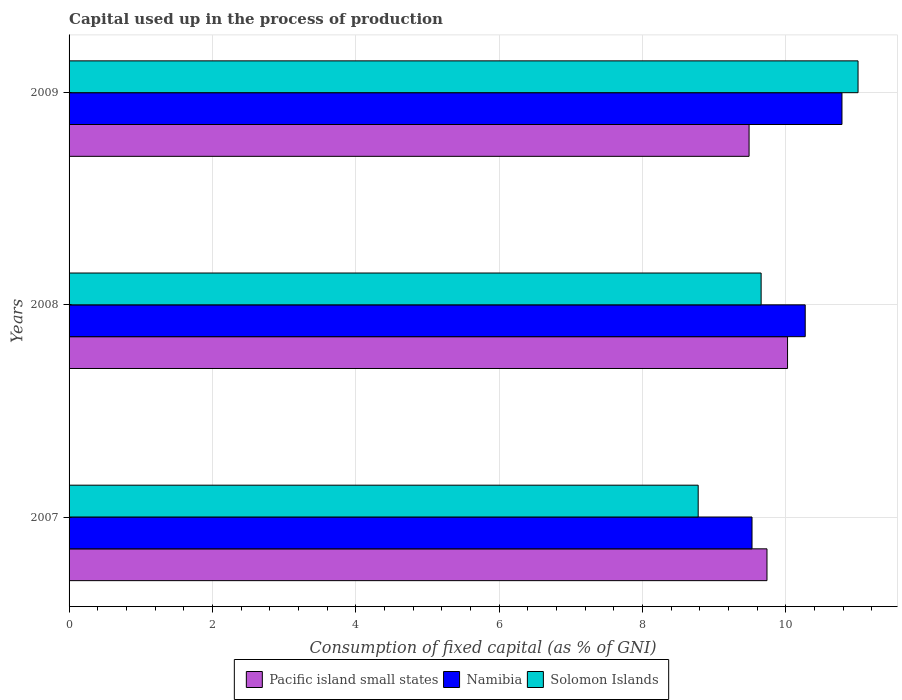How many different coloured bars are there?
Offer a terse response. 3. Are the number of bars per tick equal to the number of legend labels?
Your response must be concise. Yes. How many bars are there on the 3rd tick from the top?
Provide a succinct answer. 3. How many bars are there on the 3rd tick from the bottom?
Provide a short and direct response. 3. What is the label of the 1st group of bars from the top?
Ensure brevity in your answer.  2009. What is the capital used up in the process of production in Namibia in 2008?
Your answer should be compact. 10.27. Across all years, what is the maximum capital used up in the process of production in Solomon Islands?
Keep it short and to the point. 11.01. Across all years, what is the minimum capital used up in the process of production in Pacific island small states?
Your answer should be compact. 9.49. In which year was the capital used up in the process of production in Namibia minimum?
Ensure brevity in your answer.  2007. What is the total capital used up in the process of production in Solomon Islands in the graph?
Offer a very short reply. 29.44. What is the difference between the capital used up in the process of production in Solomon Islands in 2008 and that in 2009?
Keep it short and to the point. -1.35. What is the difference between the capital used up in the process of production in Namibia in 2008 and the capital used up in the process of production in Pacific island small states in 2007?
Ensure brevity in your answer.  0.53. What is the average capital used up in the process of production in Solomon Islands per year?
Your answer should be very brief. 9.81. In the year 2009, what is the difference between the capital used up in the process of production in Solomon Islands and capital used up in the process of production in Namibia?
Provide a short and direct response. 0.22. What is the ratio of the capital used up in the process of production in Pacific island small states in 2007 to that in 2008?
Ensure brevity in your answer.  0.97. Is the difference between the capital used up in the process of production in Solomon Islands in 2007 and 2009 greater than the difference between the capital used up in the process of production in Namibia in 2007 and 2009?
Give a very brief answer. No. What is the difference between the highest and the second highest capital used up in the process of production in Pacific island small states?
Your response must be concise. 0.29. What is the difference between the highest and the lowest capital used up in the process of production in Solomon Islands?
Offer a terse response. 2.23. In how many years, is the capital used up in the process of production in Solomon Islands greater than the average capital used up in the process of production in Solomon Islands taken over all years?
Provide a short and direct response. 1. Is the sum of the capital used up in the process of production in Namibia in 2007 and 2009 greater than the maximum capital used up in the process of production in Solomon Islands across all years?
Make the answer very short. Yes. What does the 1st bar from the top in 2007 represents?
Your answer should be very brief. Solomon Islands. What does the 2nd bar from the bottom in 2007 represents?
Offer a terse response. Namibia. Is it the case that in every year, the sum of the capital used up in the process of production in Solomon Islands and capital used up in the process of production in Pacific island small states is greater than the capital used up in the process of production in Namibia?
Provide a short and direct response. Yes. How many bars are there?
Make the answer very short. 9. Are all the bars in the graph horizontal?
Provide a short and direct response. Yes. How many years are there in the graph?
Make the answer very short. 3. Are the values on the major ticks of X-axis written in scientific E-notation?
Your answer should be compact. No. Does the graph contain any zero values?
Keep it short and to the point. No. Where does the legend appear in the graph?
Your response must be concise. Bottom center. How many legend labels are there?
Provide a short and direct response. 3. How are the legend labels stacked?
Make the answer very short. Horizontal. What is the title of the graph?
Offer a terse response. Capital used up in the process of production. What is the label or title of the X-axis?
Keep it short and to the point. Consumption of fixed capital (as % of GNI). What is the label or title of the Y-axis?
Offer a terse response. Years. What is the Consumption of fixed capital (as % of GNI) of Pacific island small states in 2007?
Make the answer very short. 9.74. What is the Consumption of fixed capital (as % of GNI) of Namibia in 2007?
Provide a short and direct response. 9.53. What is the Consumption of fixed capital (as % of GNI) in Solomon Islands in 2007?
Provide a succinct answer. 8.78. What is the Consumption of fixed capital (as % of GNI) in Pacific island small states in 2008?
Your answer should be compact. 10.03. What is the Consumption of fixed capital (as % of GNI) of Namibia in 2008?
Your answer should be compact. 10.27. What is the Consumption of fixed capital (as % of GNI) of Solomon Islands in 2008?
Ensure brevity in your answer.  9.66. What is the Consumption of fixed capital (as % of GNI) of Pacific island small states in 2009?
Provide a short and direct response. 9.49. What is the Consumption of fixed capital (as % of GNI) of Namibia in 2009?
Make the answer very short. 10.78. What is the Consumption of fixed capital (as % of GNI) in Solomon Islands in 2009?
Make the answer very short. 11.01. Across all years, what is the maximum Consumption of fixed capital (as % of GNI) of Pacific island small states?
Keep it short and to the point. 10.03. Across all years, what is the maximum Consumption of fixed capital (as % of GNI) in Namibia?
Your answer should be compact. 10.78. Across all years, what is the maximum Consumption of fixed capital (as % of GNI) of Solomon Islands?
Your response must be concise. 11.01. Across all years, what is the minimum Consumption of fixed capital (as % of GNI) in Pacific island small states?
Keep it short and to the point. 9.49. Across all years, what is the minimum Consumption of fixed capital (as % of GNI) of Namibia?
Offer a terse response. 9.53. Across all years, what is the minimum Consumption of fixed capital (as % of GNI) in Solomon Islands?
Offer a terse response. 8.78. What is the total Consumption of fixed capital (as % of GNI) of Pacific island small states in the graph?
Provide a short and direct response. 29.25. What is the total Consumption of fixed capital (as % of GNI) of Namibia in the graph?
Provide a succinct answer. 30.59. What is the total Consumption of fixed capital (as % of GNI) of Solomon Islands in the graph?
Your response must be concise. 29.44. What is the difference between the Consumption of fixed capital (as % of GNI) in Pacific island small states in 2007 and that in 2008?
Ensure brevity in your answer.  -0.29. What is the difference between the Consumption of fixed capital (as % of GNI) in Namibia in 2007 and that in 2008?
Provide a short and direct response. -0.74. What is the difference between the Consumption of fixed capital (as % of GNI) of Solomon Islands in 2007 and that in 2008?
Offer a terse response. -0.88. What is the difference between the Consumption of fixed capital (as % of GNI) of Pacific island small states in 2007 and that in 2009?
Keep it short and to the point. 0.25. What is the difference between the Consumption of fixed capital (as % of GNI) in Namibia in 2007 and that in 2009?
Keep it short and to the point. -1.26. What is the difference between the Consumption of fixed capital (as % of GNI) in Solomon Islands in 2007 and that in 2009?
Your answer should be very brief. -2.23. What is the difference between the Consumption of fixed capital (as % of GNI) in Pacific island small states in 2008 and that in 2009?
Provide a succinct answer. 0.54. What is the difference between the Consumption of fixed capital (as % of GNI) in Namibia in 2008 and that in 2009?
Offer a terse response. -0.51. What is the difference between the Consumption of fixed capital (as % of GNI) of Solomon Islands in 2008 and that in 2009?
Ensure brevity in your answer.  -1.35. What is the difference between the Consumption of fixed capital (as % of GNI) of Pacific island small states in 2007 and the Consumption of fixed capital (as % of GNI) of Namibia in 2008?
Ensure brevity in your answer.  -0.53. What is the difference between the Consumption of fixed capital (as % of GNI) in Pacific island small states in 2007 and the Consumption of fixed capital (as % of GNI) in Solomon Islands in 2008?
Provide a short and direct response. 0.08. What is the difference between the Consumption of fixed capital (as % of GNI) in Namibia in 2007 and the Consumption of fixed capital (as % of GNI) in Solomon Islands in 2008?
Ensure brevity in your answer.  -0.13. What is the difference between the Consumption of fixed capital (as % of GNI) of Pacific island small states in 2007 and the Consumption of fixed capital (as % of GNI) of Namibia in 2009?
Your answer should be very brief. -1.05. What is the difference between the Consumption of fixed capital (as % of GNI) of Pacific island small states in 2007 and the Consumption of fixed capital (as % of GNI) of Solomon Islands in 2009?
Your response must be concise. -1.27. What is the difference between the Consumption of fixed capital (as % of GNI) of Namibia in 2007 and the Consumption of fixed capital (as % of GNI) of Solomon Islands in 2009?
Your answer should be compact. -1.48. What is the difference between the Consumption of fixed capital (as % of GNI) in Pacific island small states in 2008 and the Consumption of fixed capital (as % of GNI) in Namibia in 2009?
Provide a succinct answer. -0.76. What is the difference between the Consumption of fixed capital (as % of GNI) in Pacific island small states in 2008 and the Consumption of fixed capital (as % of GNI) in Solomon Islands in 2009?
Offer a very short reply. -0.98. What is the difference between the Consumption of fixed capital (as % of GNI) in Namibia in 2008 and the Consumption of fixed capital (as % of GNI) in Solomon Islands in 2009?
Your answer should be compact. -0.74. What is the average Consumption of fixed capital (as % of GNI) of Pacific island small states per year?
Your answer should be very brief. 9.75. What is the average Consumption of fixed capital (as % of GNI) of Namibia per year?
Make the answer very short. 10.2. What is the average Consumption of fixed capital (as % of GNI) of Solomon Islands per year?
Make the answer very short. 9.81. In the year 2007, what is the difference between the Consumption of fixed capital (as % of GNI) of Pacific island small states and Consumption of fixed capital (as % of GNI) of Namibia?
Provide a succinct answer. 0.21. In the year 2007, what is the difference between the Consumption of fixed capital (as % of GNI) in Namibia and Consumption of fixed capital (as % of GNI) in Solomon Islands?
Make the answer very short. 0.75. In the year 2008, what is the difference between the Consumption of fixed capital (as % of GNI) of Pacific island small states and Consumption of fixed capital (as % of GNI) of Namibia?
Provide a succinct answer. -0.25. In the year 2008, what is the difference between the Consumption of fixed capital (as % of GNI) of Pacific island small states and Consumption of fixed capital (as % of GNI) of Solomon Islands?
Offer a terse response. 0.37. In the year 2008, what is the difference between the Consumption of fixed capital (as % of GNI) in Namibia and Consumption of fixed capital (as % of GNI) in Solomon Islands?
Make the answer very short. 0.62. In the year 2009, what is the difference between the Consumption of fixed capital (as % of GNI) in Pacific island small states and Consumption of fixed capital (as % of GNI) in Namibia?
Your answer should be very brief. -1.3. In the year 2009, what is the difference between the Consumption of fixed capital (as % of GNI) in Pacific island small states and Consumption of fixed capital (as % of GNI) in Solomon Islands?
Offer a very short reply. -1.52. In the year 2009, what is the difference between the Consumption of fixed capital (as % of GNI) of Namibia and Consumption of fixed capital (as % of GNI) of Solomon Islands?
Provide a succinct answer. -0.22. What is the ratio of the Consumption of fixed capital (as % of GNI) in Pacific island small states in 2007 to that in 2008?
Your answer should be very brief. 0.97. What is the ratio of the Consumption of fixed capital (as % of GNI) in Namibia in 2007 to that in 2008?
Provide a short and direct response. 0.93. What is the ratio of the Consumption of fixed capital (as % of GNI) of Solomon Islands in 2007 to that in 2008?
Give a very brief answer. 0.91. What is the ratio of the Consumption of fixed capital (as % of GNI) in Pacific island small states in 2007 to that in 2009?
Your response must be concise. 1.03. What is the ratio of the Consumption of fixed capital (as % of GNI) of Namibia in 2007 to that in 2009?
Give a very brief answer. 0.88. What is the ratio of the Consumption of fixed capital (as % of GNI) in Solomon Islands in 2007 to that in 2009?
Give a very brief answer. 0.8. What is the ratio of the Consumption of fixed capital (as % of GNI) in Pacific island small states in 2008 to that in 2009?
Ensure brevity in your answer.  1.06. What is the ratio of the Consumption of fixed capital (as % of GNI) in Namibia in 2008 to that in 2009?
Offer a very short reply. 0.95. What is the ratio of the Consumption of fixed capital (as % of GNI) in Solomon Islands in 2008 to that in 2009?
Give a very brief answer. 0.88. What is the difference between the highest and the second highest Consumption of fixed capital (as % of GNI) in Pacific island small states?
Ensure brevity in your answer.  0.29. What is the difference between the highest and the second highest Consumption of fixed capital (as % of GNI) in Namibia?
Your answer should be very brief. 0.51. What is the difference between the highest and the second highest Consumption of fixed capital (as % of GNI) in Solomon Islands?
Give a very brief answer. 1.35. What is the difference between the highest and the lowest Consumption of fixed capital (as % of GNI) of Pacific island small states?
Your answer should be compact. 0.54. What is the difference between the highest and the lowest Consumption of fixed capital (as % of GNI) in Namibia?
Offer a terse response. 1.26. What is the difference between the highest and the lowest Consumption of fixed capital (as % of GNI) of Solomon Islands?
Your response must be concise. 2.23. 